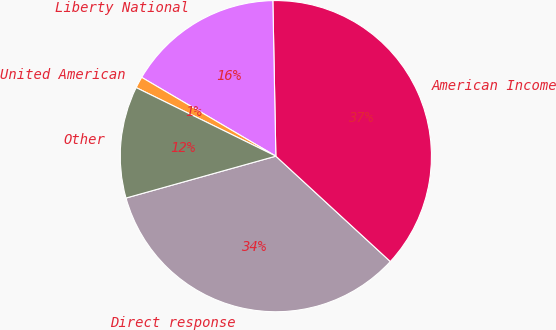<chart> <loc_0><loc_0><loc_500><loc_500><pie_chart><fcel>Direct response<fcel>American Income<fcel>Liberty National<fcel>United American<fcel>Other<nl><fcel>33.82%<fcel>37.15%<fcel>16.24%<fcel>1.19%<fcel>11.6%<nl></chart> 